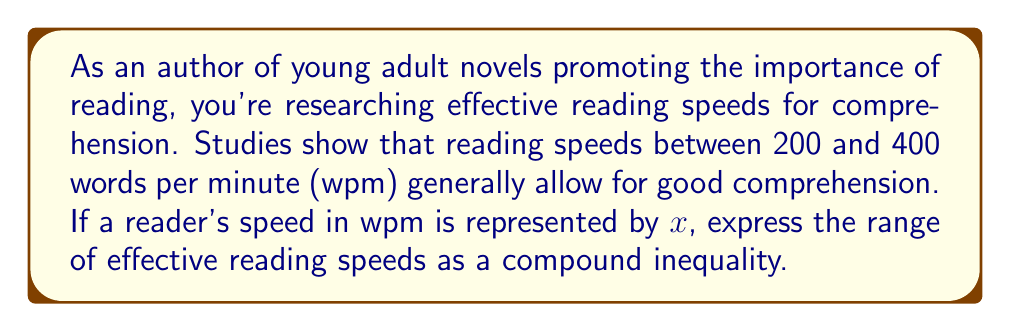Teach me how to tackle this problem. To express the range of effective reading speeds as a compound inequality, we need to represent the lower and upper bounds of the range:

1. Lower bound: The minimum effective reading speed is 200 wpm.
   This can be expressed as: $x \geq 200$

2. Upper bound: The maximum effective reading speed is 400 wpm.
   This can be expressed as: $x \leq 400$

3. To combine these inequalities into a compound inequality, we use the "and" condition, represented by the $\land$ symbol:

   $200 \leq x \leq 400$

This compound inequality represents all values of $x$ that are simultaneously greater than or equal to 200 and less than or equal to 400.

In interval notation, this would be written as $[200, 400]$.
Answer: $200 \leq x \leq 400$ 